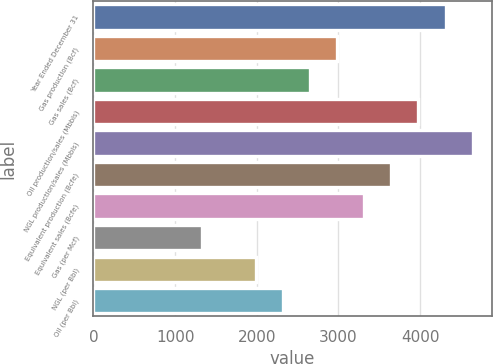Convert chart. <chart><loc_0><loc_0><loc_500><loc_500><bar_chart><fcel>Year Ended December 31<fcel>Gas production (Bcf)<fcel>Gas sales (Bcf)<fcel>Oil production/sales (Mbbls)<fcel>NGL production/sales (Mbbls)<fcel>Equivalent production (Bcfe)<fcel>Equivalent sales (Bcfe)<fcel>Gas (per Mcf)<fcel>NGL (per Bbl)<fcel>Oil (per Bbl)<nl><fcel>4310.51<fcel>2984.31<fcel>2652.76<fcel>3978.96<fcel>4642.06<fcel>3647.41<fcel>3315.86<fcel>1326.56<fcel>1989.66<fcel>2321.21<nl></chart> 